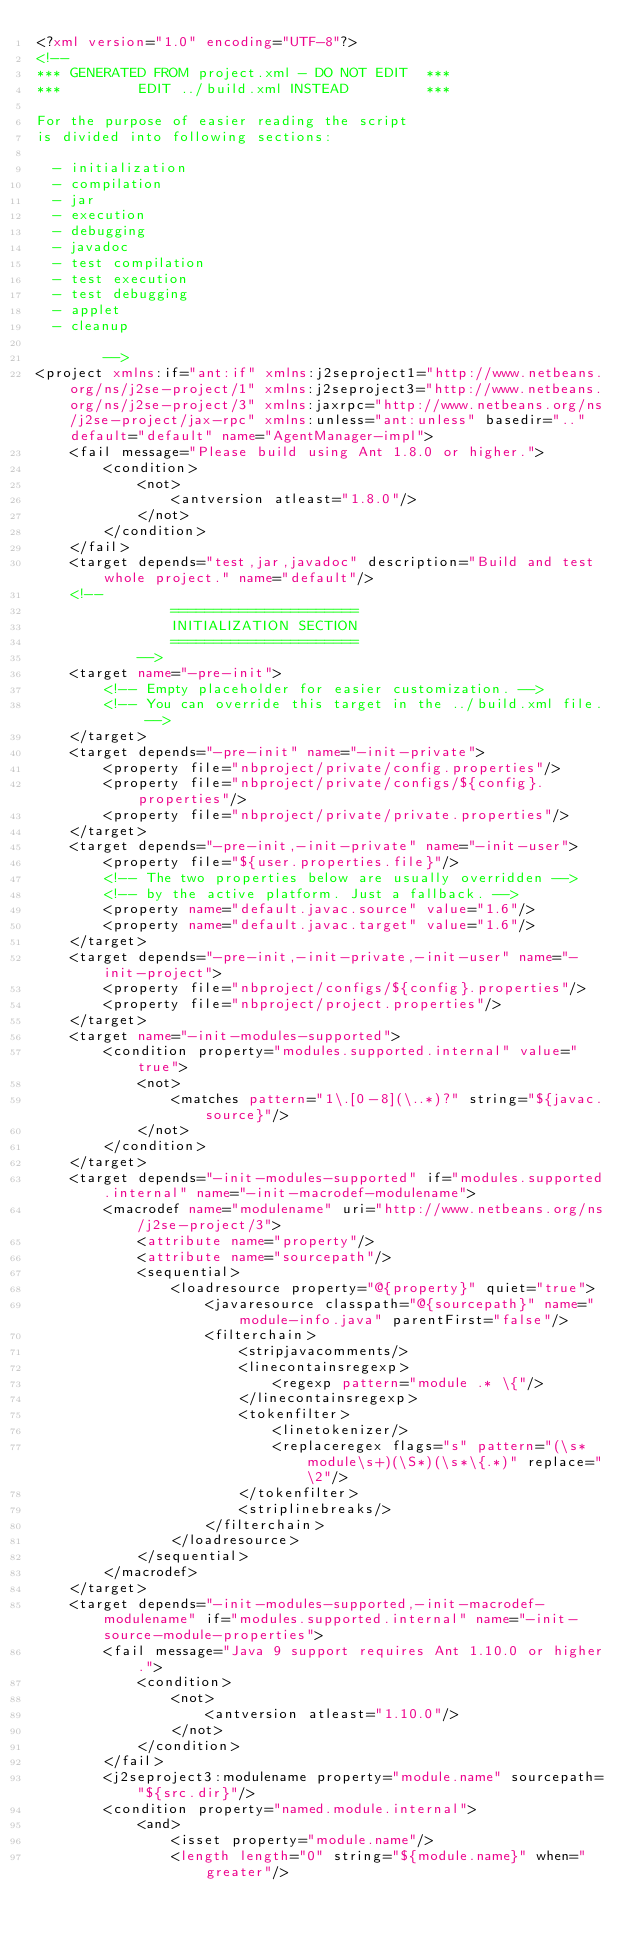Convert code to text. <code><loc_0><loc_0><loc_500><loc_500><_XML_><?xml version="1.0" encoding="UTF-8"?>
<!--
*** GENERATED FROM project.xml - DO NOT EDIT  ***
***         EDIT ../build.xml INSTEAD         ***

For the purpose of easier reading the script
is divided into following sections:

  - initialization
  - compilation
  - jar
  - execution
  - debugging
  - javadoc
  - test compilation
  - test execution
  - test debugging
  - applet
  - cleanup

        -->
<project xmlns:if="ant:if" xmlns:j2seproject1="http://www.netbeans.org/ns/j2se-project/1" xmlns:j2seproject3="http://www.netbeans.org/ns/j2se-project/3" xmlns:jaxrpc="http://www.netbeans.org/ns/j2se-project/jax-rpc" xmlns:unless="ant:unless" basedir=".." default="default" name="AgentManager-impl">
    <fail message="Please build using Ant 1.8.0 or higher.">
        <condition>
            <not>
                <antversion atleast="1.8.0"/>
            </not>
        </condition>
    </fail>
    <target depends="test,jar,javadoc" description="Build and test whole project." name="default"/>
    <!-- 
                ======================
                INITIALIZATION SECTION 
                ======================
            -->
    <target name="-pre-init">
        <!-- Empty placeholder for easier customization. -->
        <!-- You can override this target in the ../build.xml file. -->
    </target>
    <target depends="-pre-init" name="-init-private">
        <property file="nbproject/private/config.properties"/>
        <property file="nbproject/private/configs/${config}.properties"/>
        <property file="nbproject/private/private.properties"/>
    </target>
    <target depends="-pre-init,-init-private" name="-init-user">
        <property file="${user.properties.file}"/>
        <!-- The two properties below are usually overridden -->
        <!-- by the active platform. Just a fallback. -->
        <property name="default.javac.source" value="1.6"/>
        <property name="default.javac.target" value="1.6"/>
    </target>
    <target depends="-pre-init,-init-private,-init-user" name="-init-project">
        <property file="nbproject/configs/${config}.properties"/>
        <property file="nbproject/project.properties"/>
    </target>
    <target name="-init-modules-supported">
        <condition property="modules.supported.internal" value="true">
            <not>
                <matches pattern="1\.[0-8](\..*)?" string="${javac.source}"/>
            </not>
        </condition>
    </target>
    <target depends="-init-modules-supported" if="modules.supported.internal" name="-init-macrodef-modulename">
        <macrodef name="modulename" uri="http://www.netbeans.org/ns/j2se-project/3">
            <attribute name="property"/>
            <attribute name="sourcepath"/>
            <sequential>
                <loadresource property="@{property}" quiet="true">
                    <javaresource classpath="@{sourcepath}" name="module-info.java" parentFirst="false"/>
                    <filterchain>
                        <stripjavacomments/>
                        <linecontainsregexp>
                            <regexp pattern="module .* \{"/>
                        </linecontainsregexp>
                        <tokenfilter>
                            <linetokenizer/>
                            <replaceregex flags="s" pattern="(\s*module\s+)(\S*)(\s*\{.*)" replace="\2"/>
                        </tokenfilter>
                        <striplinebreaks/>
                    </filterchain>
                </loadresource>
            </sequential>
        </macrodef>
    </target>
    <target depends="-init-modules-supported,-init-macrodef-modulename" if="modules.supported.internal" name="-init-source-module-properties">
        <fail message="Java 9 support requires Ant 1.10.0 or higher.">
            <condition>
                <not>
                    <antversion atleast="1.10.0"/>
                </not>
            </condition>
        </fail>
        <j2seproject3:modulename property="module.name" sourcepath="${src.dir}"/>
        <condition property="named.module.internal">
            <and>
                <isset property="module.name"/>
                <length length="0" string="${module.name}" when="greater"/></code> 